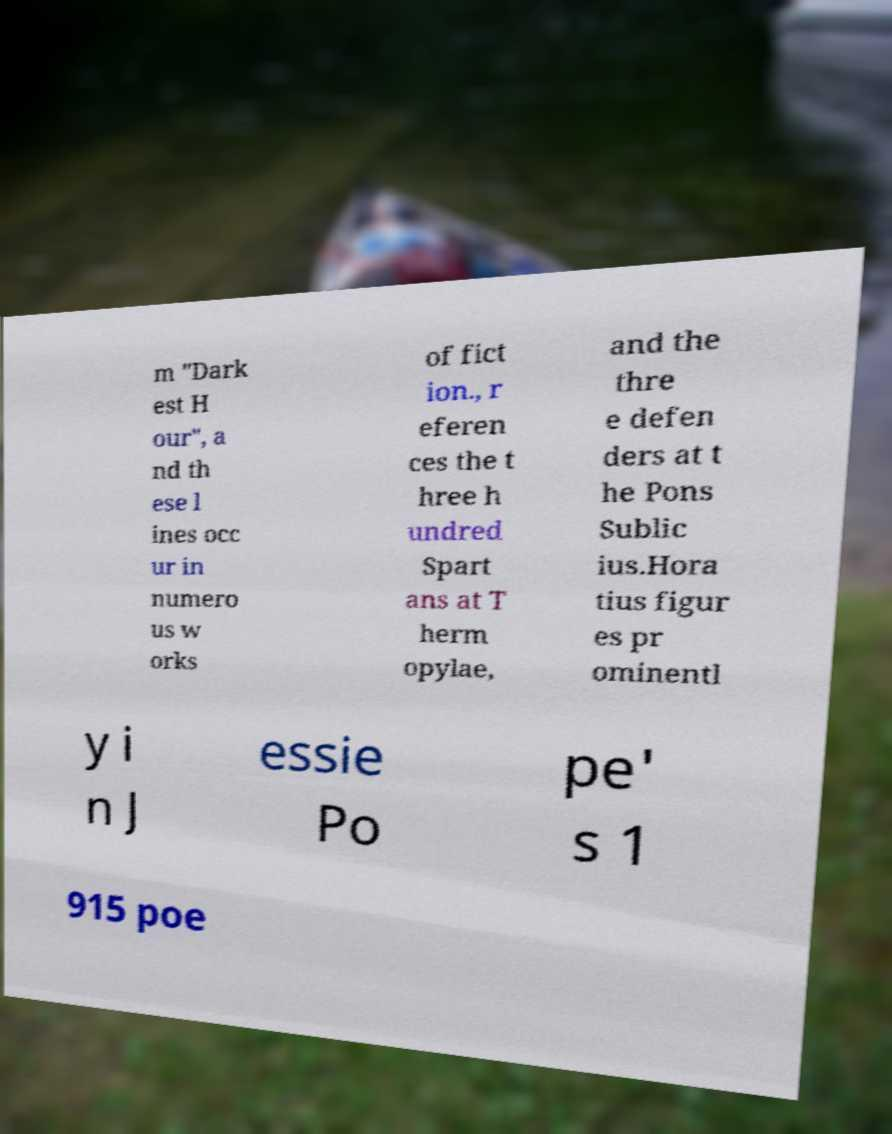What messages or text are displayed in this image? I need them in a readable, typed format. m "Dark est H our", a nd th ese l ines occ ur in numero us w orks of fict ion., r eferen ces the t hree h undred Spart ans at T herm opylae, and the thre e defen ders at t he Pons Sublic ius.Hora tius figur es pr ominentl y i n J essie Po pe' s 1 915 poe 